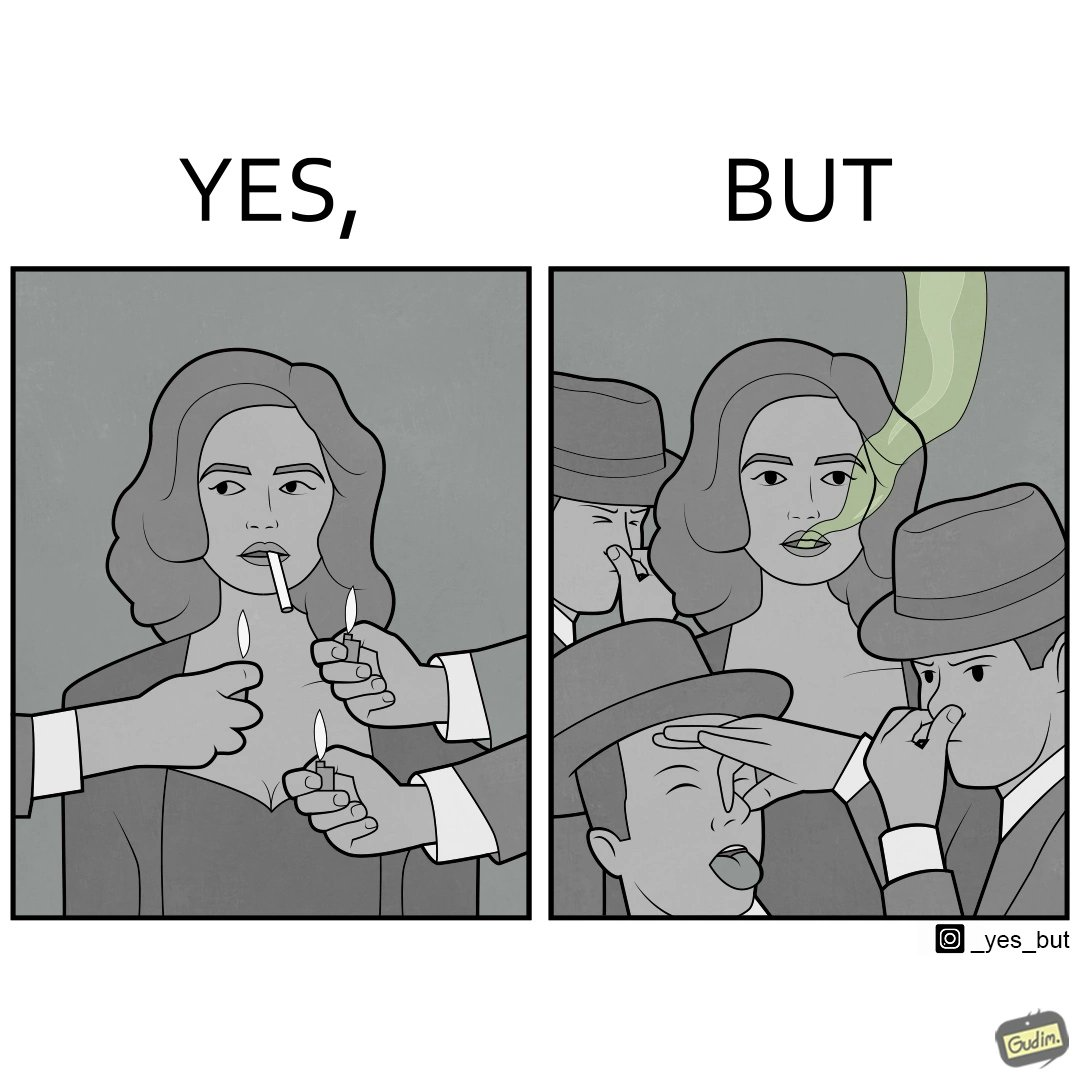Would you classify this image as satirical? Yes, this image is satirical. 